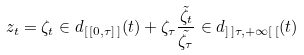<formula> <loc_0><loc_0><loc_500><loc_500>z _ { t } = \zeta _ { t } \in d _ { [ \, [ 0 , \tau ] \, ] } ( t ) + \zeta _ { \tau } \frac { \tilde { \zeta _ { t } } } { \tilde { \zeta _ { \tau } } } \in d _ { ] \, ] \tau , + \infty [ \, [ } ( t )</formula> 